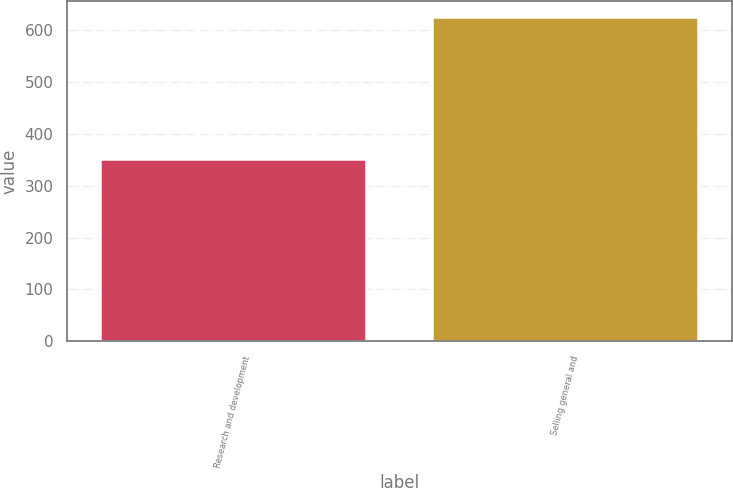<chart> <loc_0><loc_0><loc_500><loc_500><bar_chart><fcel>Research and development<fcel>Selling general and<nl><fcel>351<fcel>625<nl></chart> 